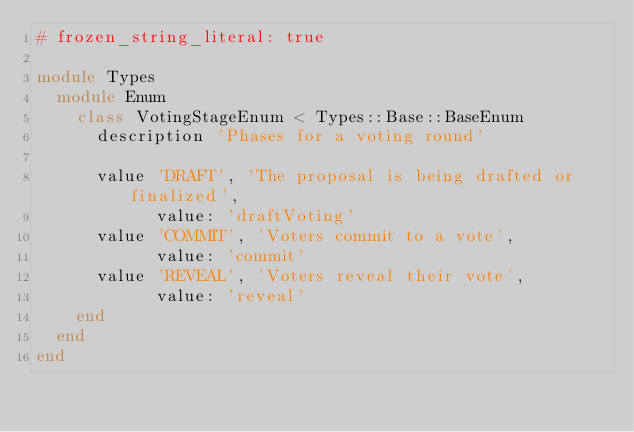<code> <loc_0><loc_0><loc_500><loc_500><_Ruby_># frozen_string_literal: true

module Types
  module Enum
    class VotingStageEnum < Types::Base::BaseEnum
      description 'Phases for a voting round'

      value 'DRAFT', 'The proposal is being drafted or finalized',
            value: 'draftVoting'
      value 'COMMIT', 'Voters commit to a vote',
            value: 'commit'
      value 'REVEAL', 'Voters reveal their vote',
            value: 'reveal'
    end
  end
end
</code> 